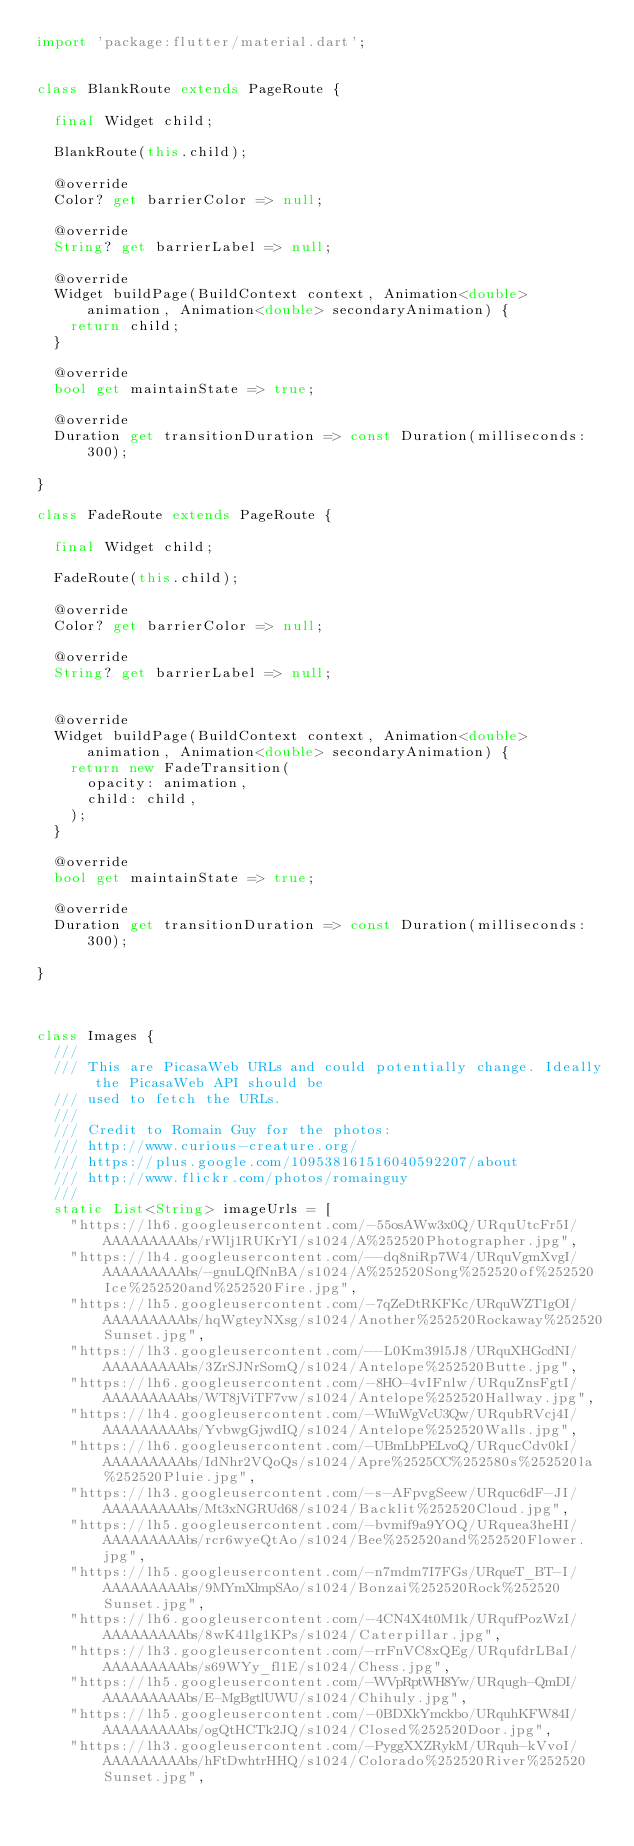<code> <loc_0><loc_0><loc_500><loc_500><_Dart_>import 'package:flutter/material.dart';


class BlankRoute extends PageRoute {

  final Widget child;

  BlankRoute(this.child);

  @override
  Color? get barrierColor => null;

  @override
  String? get barrierLabel => null;

  @override
  Widget buildPage(BuildContext context, Animation<double> animation, Animation<double> secondaryAnimation) {
    return child;
  }

  @override
  bool get maintainState => true;

  @override
  Duration get transitionDuration => const Duration(milliseconds: 300);

}

class FadeRoute extends PageRoute {

  final Widget child;

  FadeRoute(this.child);

  @override
  Color? get barrierColor => null;

  @override
  String? get barrierLabel => null;


  @override
  Widget buildPage(BuildContext context, Animation<double> animation, Animation<double> secondaryAnimation) {
    return new FadeTransition(
      opacity: animation,
      child: child,
    );
  }

  @override
  bool get maintainState => true;

  @override
  Duration get transitionDuration => const Duration(milliseconds: 300);

}



class Images {
  ///
  /// This are PicasaWeb URLs and could potentially change. Ideally the PicasaWeb API should be
  /// used to fetch the URLs.
  ///
  /// Credit to Romain Guy for the photos:
  /// http://www.curious-creature.org/
  /// https://plus.google.com/109538161516040592207/about
  /// http://www.flickr.com/photos/romainguy
  ///
  static List<String> imageUrls = [
    "https://lh6.googleusercontent.com/-55osAWw3x0Q/URquUtcFr5I/AAAAAAAAAbs/rWlj1RUKrYI/s1024/A%252520Photographer.jpg",
    "https://lh4.googleusercontent.com/--dq8niRp7W4/URquVgmXvgI/AAAAAAAAAbs/-gnuLQfNnBA/s1024/A%252520Song%252520of%252520Ice%252520and%252520Fire.jpg",
    "https://lh5.googleusercontent.com/-7qZeDtRKFKc/URquWZT1gOI/AAAAAAAAAbs/hqWgteyNXsg/s1024/Another%252520Rockaway%252520Sunset.jpg",
    "https://lh3.googleusercontent.com/--L0Km39l5J8/URquXHGcdNI/AAAAAAAAAbs/3ZrSJNrSomQ/s1024/Antelope%252520Butte.jpg",
    "https://lh6.googleusercontent.com/-8HO-4vIFnlw/URquZnsFgtI/AAAAAAAAAbs/WT8jViTF7vw/s1024/Antelope%252520Hallway.jpg",
    "https://lh4.googleusercontent.com/-WIuWgVcU3Qw/URqubRVcj4I/AAAAAAAAAbs/YvbwgGjwdIQ/s1024/Antelope%252520Walls.jpg",
    "https://lh6.googleusercontent.com/-UBmLbPELvoQ/URqucCdv0kI/AAAAAAAAAbs/IdNhr2VQoQs/s1024/Apre%2525CC%252580s%252520la%252520Pluie.jpg",
    "https://lh3.googleusercontent.com/-s-AFpvgSeew/URquc6dF-JI/AAAAAAAAAbs/Mt3xNGRUd68/s1024/Backlit%252520Cloud.jpg",
    "https://lh5.googleusercontent.com/-bvmif9a9YOQ/URquea3heHI/AAAAAAAAAbs/rcr6wyeQtAo/s1024/Bee%252520and%252520Flower.jpg",
    "https://lh5.googleusercontent.com/-n7mdm7I7FGs/URqueT_BT-I/AAAAAAAAAbs/9MYmXlmpSAo/s1024/Bonzai%252520Rock%252520Sunset.jpg",
    "https://lh6.googleusercontent.com/-4CN4X4t0M1k/URqufPozWzI/AAAAAAAAAbs/8wK41lg1KPs/s1024/Caterpillar.jpg",
    "https://lh3.googleusercontent.com/-rrFnVC8xQEg/URqufdrLBaI/AAAAAAAAAbs/s69WYy_fl1E/s1024/Chess.jpg",
    "https://lh5.googleusercontent.com/-WVpRptWH8Yw/URqugh-QmDI/AAAAAAAAAbs/E-MgBgtlUWU/s1024/Chihuly.jpg",
    "https://lh5.googleusercontent.com/-0BDXkYmckbo/URquhKFW84I/AAAAAAAAAbs/ogQtHCTk2JQ/s1024/Closed%252520Door.jpg",
    "https://lh3.googleusercontent.com/-PyggXXZRykM/URquh-kVvoI/AAAAAAAAAbs/hFtDwhtrHHQ/s1024/Colorado%252520River%252520Sunset.jpg",</code> 